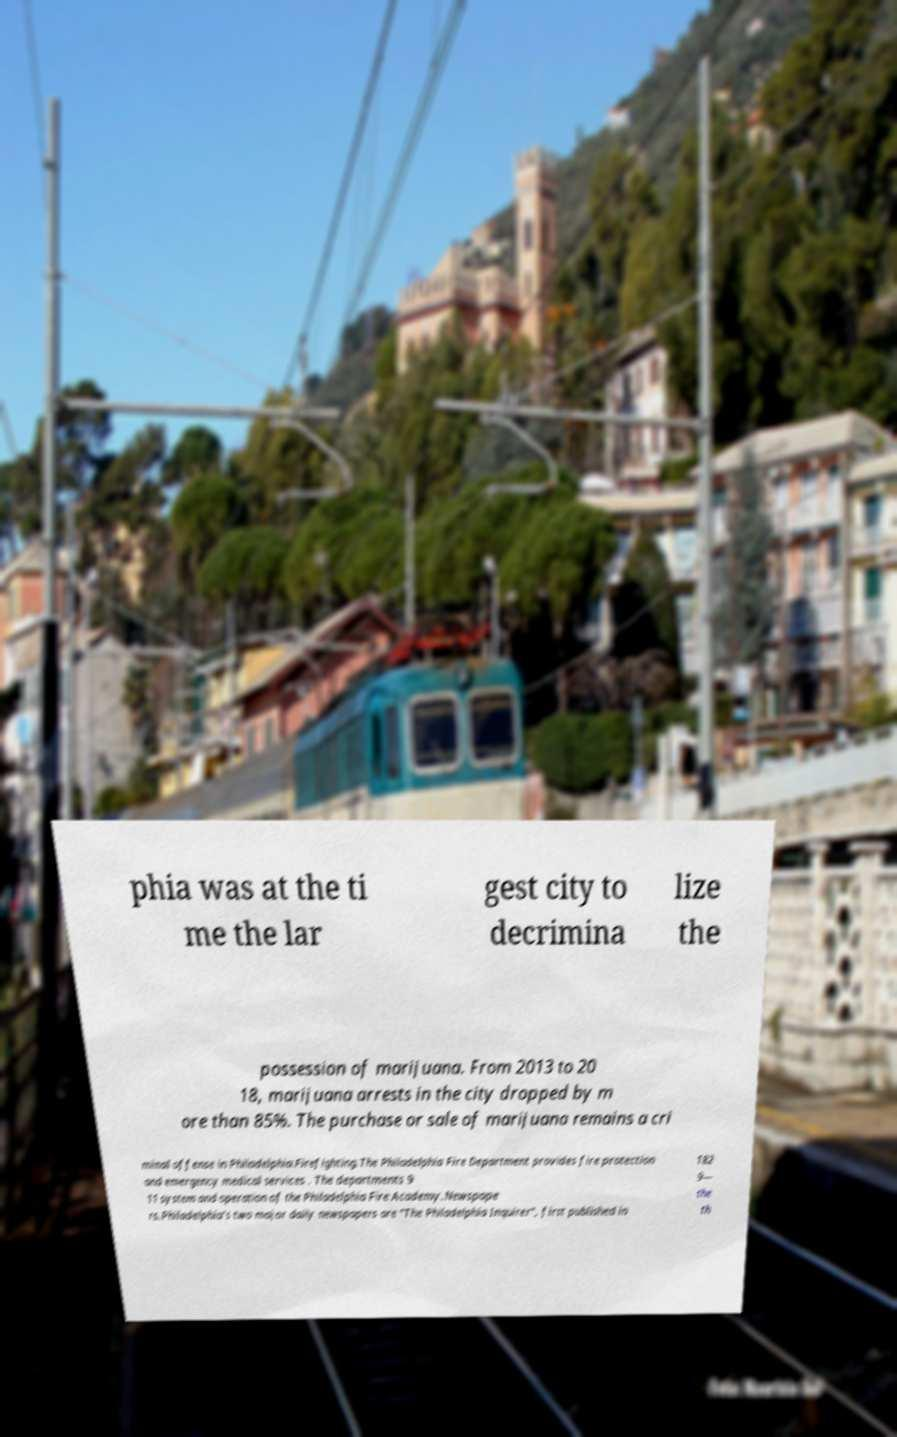There's text embedded in this image that I need extracted. Can you transcribe it verbatim? phia was at the ti me the lar gest city to decrimina lize the possession of marijuana. From 2013 to 20 18, marijuana arrests in the city dropped by m ore than 85%. The purchase or sale of marijuana remains a cri minal offense in Philadelphia.Firefighting.The Philadelphia Fire Department provides fire protection and emergency medical services . The departments 9 11 system and operation of the Philadelphia Fire Academy.Newspape rs.Philadelphia's two major daily newspapers are "The Philadelphia Inquirer", first published in 182 9— the th 